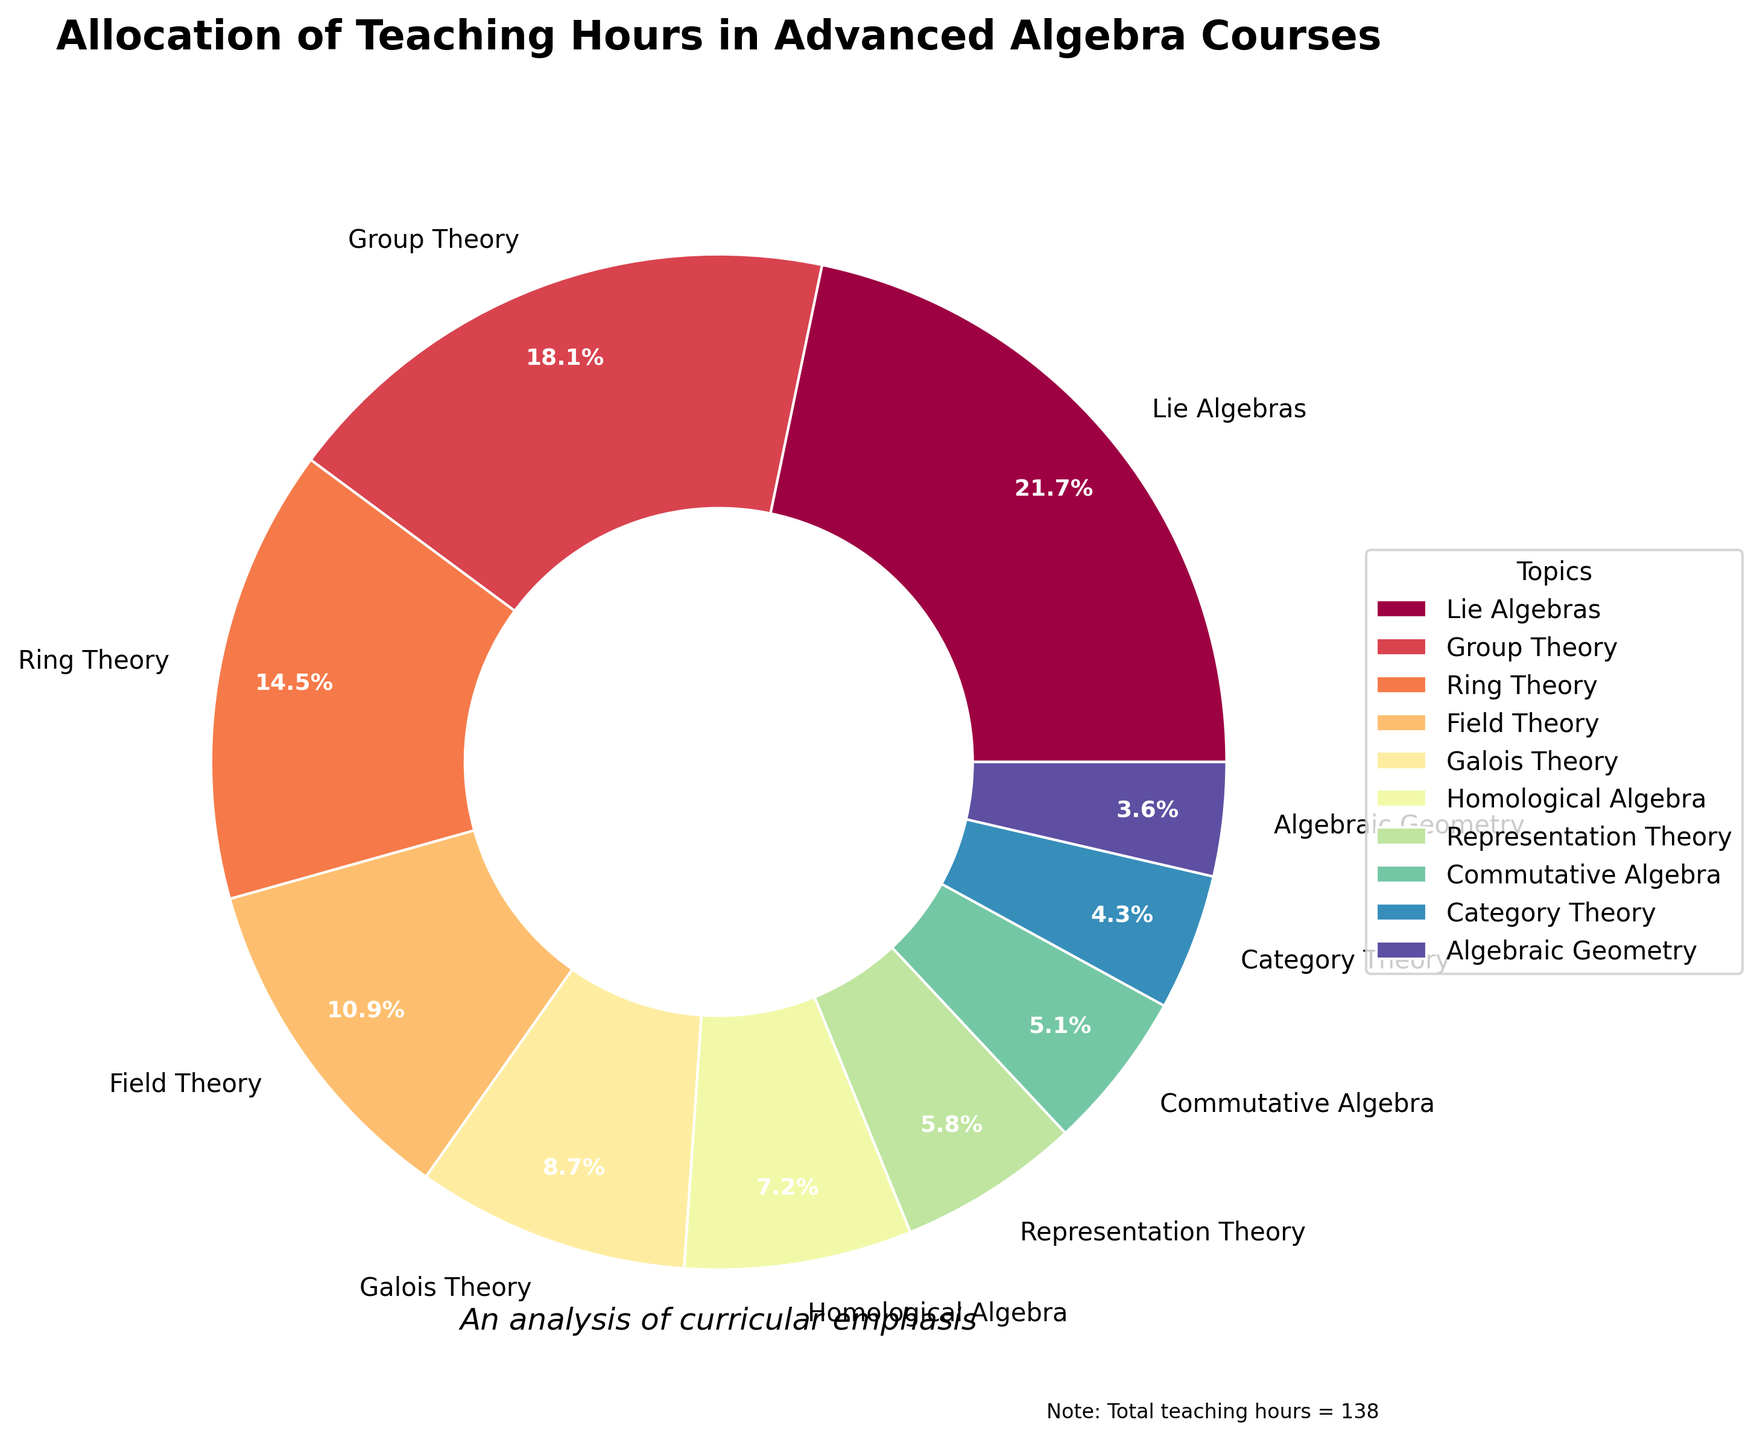Which topic was allocated the most teaching hours? By looking at the wedges in the pie chart, the largest portion corresponds to the topic with the most teaching hours. The segment representing Lie Algebras is the largest.
Answer: Lie Algebras How many more hours are allocated to Lie Algebras compared to Algebraic Geometry? Lie Algebras have 30 hours, and Algebraic Geometry has 5 hours. The difference is calculated as 30 - 5.
Answer: 25 What percentage of the total hours is allocated to Ring Theory? Ring Theory is allocated 20 hours out of the total 138 hours. The percentage is \((20/138) \times 100\ \approx 14.5\%\).
Answer: 14.5% Which topic has received fewer teaching hours: Homological Algebra or Representation Theory? By comparing the size of wedges, Representation Theory has 8 hours, whereas Homological Algebra has 10 hours. Hence, Representation Theory has fewer hours.
Answer: Representation Theory What's the combined percentage of hours allocated to Group Theory and Field Theory? Group Theory is 18.1% and Field Theory is 10.9%. Combined percentage = \(18.1 + 10.9 = 29\%\).
Answer: 29% Which topics account for less than 10% of the total teaching hours? Wedges representing percentages less than 10% are Galois Theory, Homological Algebra, Representation Theory, Commutative Algebra, Category Theory, and Algebraic Geometry.
Answer: Galois Theory, Homological Algebra, Representation Theory, Commutative Algebra, Category Theory, Algebraic Geometry Identify the topic represented with the darkest color on the pie chart. The darkest color typically appears last in a gradient color scheme. The topic with the darkest wedge is Algebraic Geometry.
Answer: Algebraic Geometry How much less teaching time is given to Category Theory compared to Group Theory? Group Theory has 25 hours and Category Theory has 6 hours. The difference is \(25 - 6 = 19\) hours.
Answer: 19 If one additional hour were allocated to every topic, what would the new total teaching hours be? The current total teaching hours is 138. Adding 1 hour to each topic (10 topics) results in \(138 + 10 = 148\) hours.
Answer: 148 What is the average number of teaching hours allocated across all topics? Sum of hours is 138. Number of topics is 10. Average = \(138 / 10 = 13.8\).
Answer: 13.8 